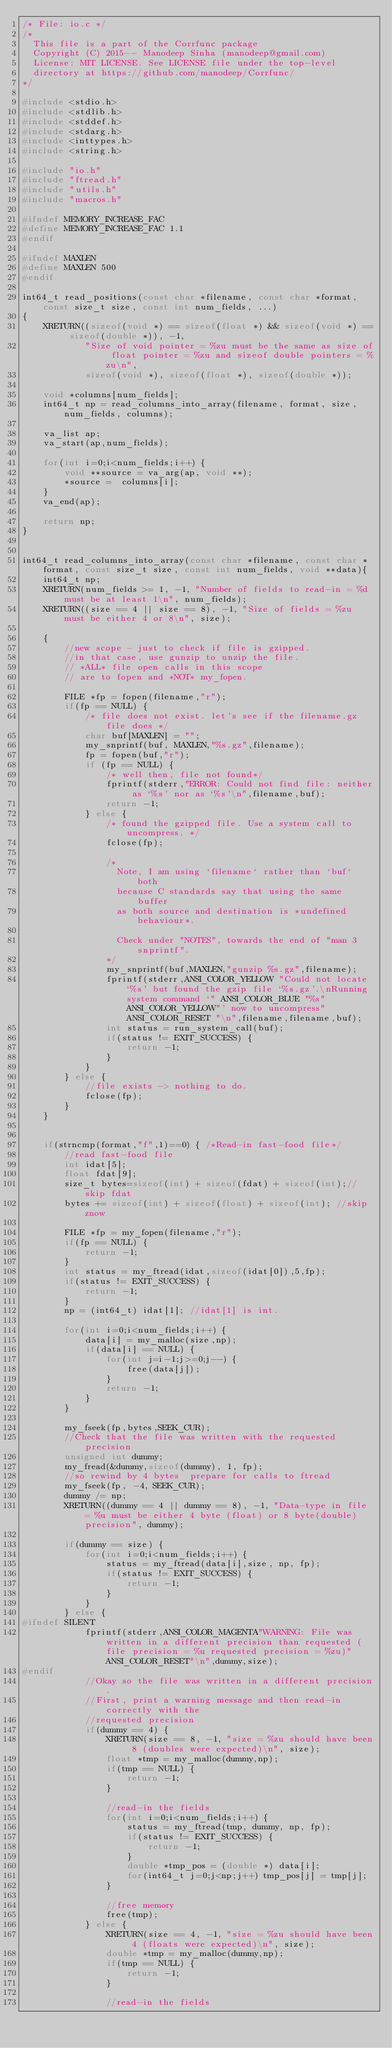<code> <loc_0><loc_0><loc_500><loc_500><_C_>/* File: io.c */
/*
  This file is a part of the Corrfunc package
  Copyright (C) 2015-- Manodeep Sinha (manodeep@gmail.com)
  License: MIT LICENSE. See LICENSE file under the top-level
  directory at https://github.com/manodeep/Corrfunc/
*/

#include <stdio.h>
#include <stdlib.h>
#include <stddef.h>
#include <stdarg.h>
#include <inttypes.h>
#include <string.h>

#include "io.h"
#include "ftread.h"
#include "utils.h"
#include "macros.h"

#ifndef MEMORY_INCREASE_FAC
#define MEMORY_INCREASE_FAC 1.1
#endif

#ifndef MAXLEN
#define MAXLEN 500
#endif

int64_t read_positions(const char *filename, const char *format, const size_t size, const int num_fields, ...)
{
    XRETURN((sizeof(void *) == sizeof(float *) && sizeof(void *) == sizeof(double *)), -1,
            "Size of void pointer = %zu must be the same as size of float pointer = %zu and sizeof double pointers = %zu\n",
            sizeof(void *), sizeof(float *), sizeof(double *));
            
    void *columns[num_fields];
    int64_t np = read_columns_into_array(filename, format, size, num_fields, columns);
    
    va_list ap;
    va_start(ap,num_fields);
    
    for(int i=0;i<num_fields;i++) {
        void **source = va_arg(ap, void **);
        *source =  columns[i];
    }
    va_end(ap);

    return np;
}


int64_t read_columns_into_array(const char *filename, const char *format, const size_t size, const int num_fields, void **data){
    int64_t np;
    XRETURN(num_fields >= 1, -1, "Number of fields to read-in = %d must be at least 1\n", num_fields);
    XRETURN((size == 4 || size == 8), -1, "Size of fields = %zu must be either 4 or 8\n", size);
    
    {
        //new scope - just to check if file is gzipped.
        //in that case, use gunzip to unzip the file.
        // *ALL* file open calls in this scope
        // are to fopen and *NOT* my_fopen.

        FILE *fp = fopen(filename,"r");
        if(fp == NULL) {
            /* file does not exist. let's see if the filename.gz file does */
            char buf[MAXLEN] = "";
            my_snprintf(buf, MAXLEN,"%s.gz",filename);
            fp = fopen(buf,"r");
            if (fp == NULL) {
                /* well then, file not found*/
                fprintf(stderr,"ERROR: Could not find file: neither as `%s' nor as `%s'\n",filename,buf);
                return -1;
            } else {
                /* found the gzipped file. Use a system call to uncompress. */
                fclose(fp);

                /*
                  Note, I am using `filename` rather than `buf` both
                  because C standards say that using the same buffer
                  as both source and destination is *undefined behaviour*.

                  Check under "NOTES", towards the end of "man 3 snprintf".
                */
                my_snprintf(buf,MAXLEN,"gunzip %s.gz",filename);
                fprintf(stderr,ANSI_COLOR_YELLOW "Could not locate `%s' but found the gzip file `%s.gz'.\nRunning system command `" ANSI_COLOR_BLUE "%s"ANSI_COLOR_YELLOW"' now to uncompress"ANSI_COLOR_RESET "\n",filename,filename,buf);
                int status = run_system_call(buf);
                if(status != EXIT_SUCCESS) {
                    return -1;
                }
            }
        } else {
            //file exists -> nothing to do.
            fclose(fp);
        }
    }


    if(strncmp(format,"f",1)==0) { /*Read-in fast-food file*/
        //read fast-food file
        int idat[5];
        float fdat[9];
        size_t bytes=sizeof(int) + sizeof(fdat) + sizeof(int);//skip fdat
        bytes += sizeof(int) + sizeof(float) + sizeof(int); //skip znow

        FILE *fp = my_fopen(filename,"r");
        if(fp == NULL) {
            return -1;
        }
        int status = my_ftread(idat,sizeof(idat[0]),5,fp);
        if(status != EXIT_SUCCESS) {
            return -1;
        }
        np = (int64_t) idat[1]; //idat[1] is int.

        for(int i=0;i<num_fields;i++) {
            data[i] = my_malloc(size,np);
            if(data[i] == NULL) {
                for(int j=i-1;j>=0;j--) {
                    free(data[j]);
                }
                return -1;
            }
        }

        my_fseek(fp,bytes,SEEK_CUR);
        //Check that the file was written with the requested precision
        unsigned int dummy;
        my_fread(&dummy,sizeof(dummy), 1, fp);
        //so rewind by 4 bytes  prepare for calls to ftread
        my_fseek(fp, -4, SEEK_CUR);
        dummy /= np;
        XRETURN((dummy == 4 || dummy == 8), -1, "Data-type in file = %u must be either 4 byte (float) or 8 byte(double) precision", dummy);

        if(dummy == size) {
            for(int i=0;i<num_fields;i++) {
                status = my_ftread(data[i],size, np, fp);
                if(status != EXIT_SUCCESS) {
                    return -1;
                }
            }
        } else {
#ifndef SILENT
            fprintf(stderr,ANSI_COLOR_MAGENTA"WARNING: File was written in a different precision than requested (file precision = %u requested precision = %zu)"ANSI_COLOR_RESET"\n",dummy,size);
#endif
            //Okay so the file was written in a different precision.
            //First, print a warning message and then read-in correctly with the
            //requested precision
            if(dummy == 4) {
                XRETURN(size == 8, -1, "size = %zu should have been 8 (doubles were expected)\n", size);
                float *tmp = my_malloc(dummy,np);
                if(tmp == NULL) {
                    return -1;
                }
                
                //read-in the fields
                for(int i=0;i<num_fields;i++) {
                    status = my_ftread(tmp, dummy, np, fp);
                    if(status != EXIT_SUCCESS) {
                        return -1;
                    }
                    double *tmp_pos = (double *) data[i];
                    for(int64_t j=0;j<np;j++) tmp_pos[j] = tmp[j];
                }

                //free memory
                free(tmp);
            } else {
                XRETURN(size == 4, -1, "size = %zu should have been 4 (floats were expected)\n", size);
                double *tmp = my_malloc(dummy,np);
                if(tmp == NULL) {
                    return -1;
                }

                //read-in the fields</code> 